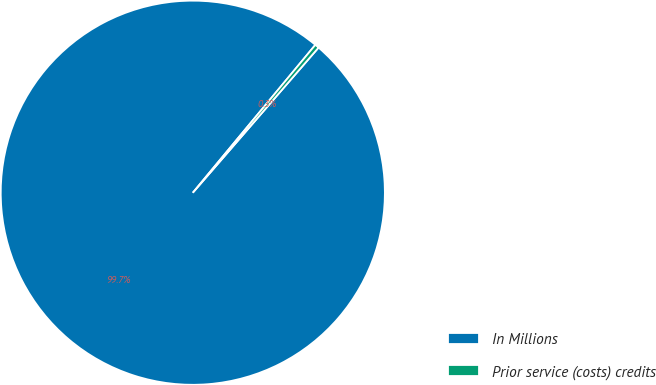<chart> <loc_0><loc_0><loc_500><loc_500><pie_chart><fcel>In Millions<fcel>Prior service (costs) credits<nl><fcel>99.65%<fcel>0.35%<nl></chart> 